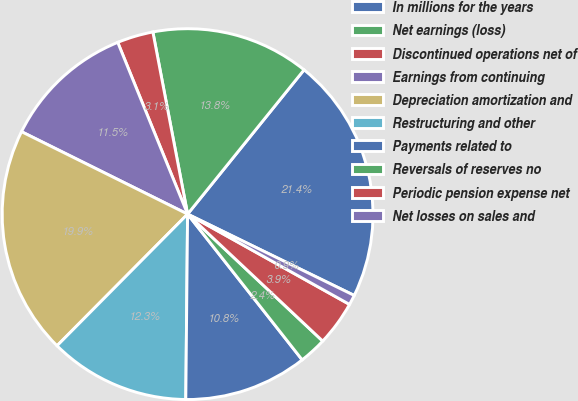Convert chart. <chart><loc_0><loc_0><loc_500><loc_500><pie_chart><fcel>In millions for the years<fcel>Net earnings (loss)<fcel>Discontinued operations net of<fcel>Earnings from continuing<fcel>Depreciation amortization and<fcel>Restructuring and other<fcel>Payments related to<fcel>Reversals of reserves no<fcel>Periodic pension expense net<fcel>Net losses on sales and<nl><fcel>21.42%<fcel>13.81%<fcel>3.15%<fcel>11.52%<fcel>19.9%<fcel>12.28%<fcel>10.76%<fcel>2.39%<fcel>3.91%<fcel>0.87%<nl></chart> 